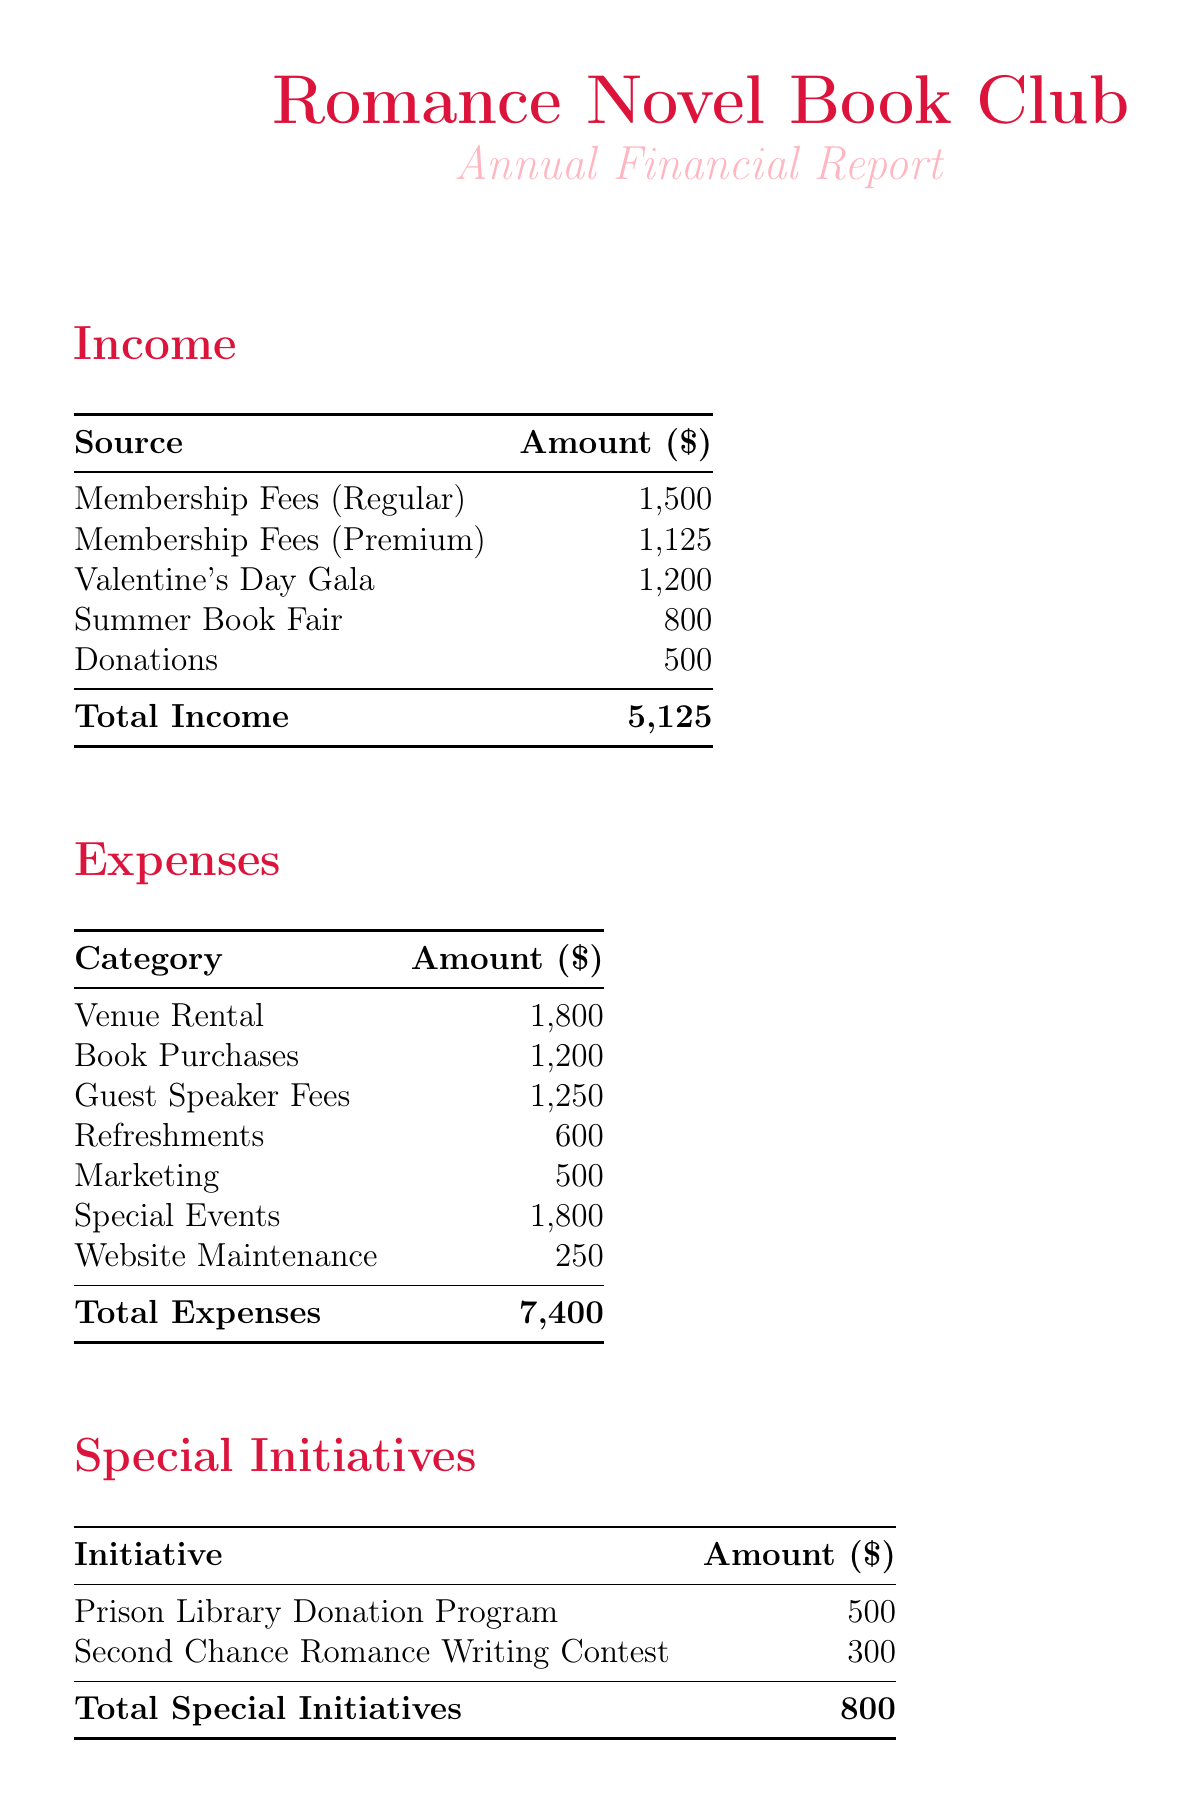what is the total income? The total income is the sum of all sources of income in the document, which is 1500 + 1125 + 1200 + 800 + 500 = 5125.
Answer: 5125 what is the total expenses? The total expenses is the sum of all categories of expenses listed in the document, which is 1800 + 1200 + 1250 + 600 + 500 + 1800 + 250 = 7400.
Answer: 7400 how much is allocated for the prison library donation program? The document specifies 500 for the prison library donation program under special initiatives.
Answer: 500 who is the guest speaker with the highest fee? The document lists Nora Roberts with a fee of 500 and Nicholas Sparks with a fee of 750, making Nicholas Sparks the highest.
Answer: Nicholas Sparks what is the net balance for the year? The net balance is calculated as total income minus total expenses, which is 5125 - 7400 = -3075.
Answer: -3075 what is the amount allocated for book purchases? The document indicates an annual total for book purchases of 1200.
Answer: 1200 how much was raised from the Valentine's Day Gala? The document states that the Valentine's Day Gala raised 1200.
Answer: 1200 what is the total amount spent on special events? The total amount spent on special events, as listed in the expenses, is 1000 for the annual retreat and 800 for the charity ball, totaling 1800.
Answer: 1800 how much is allocated for marketing? The document lists a total of 500 allocated for marketing, which includes social media ads and flyers and posters.
Answer: 500 